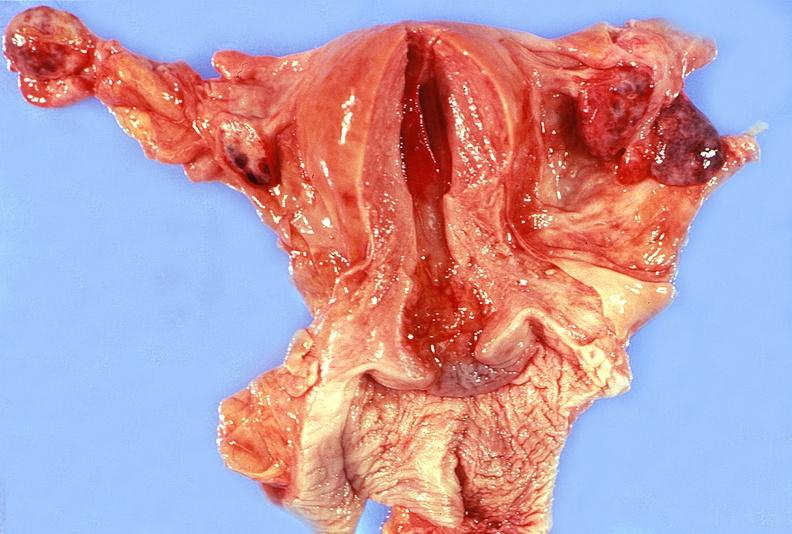does chronic ischemia show uterus, fallopian tubes, ovaries ; normal?
Answer the question using a single word or phrase. No 